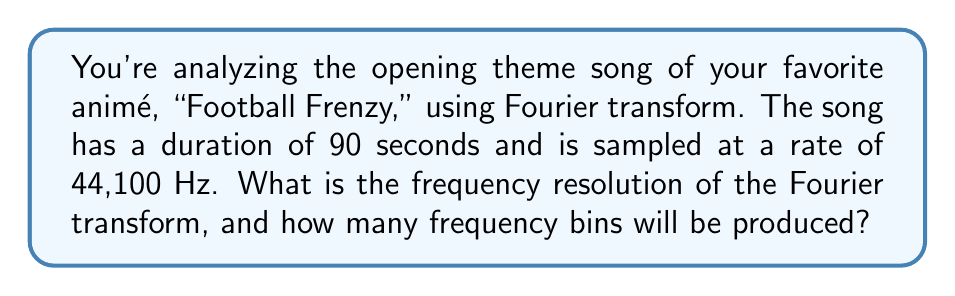Give your solution to this math problem. To solve this problem, we need to understand two key concepts of the Fourier transform:

1. Frequency resolution
2. Number of frequency bins

Let's break it down step-by-step:

1. Frequency Resolution:
   The frequency resolution (Δf) is given by the formula:
   
   $$\Delta f = \frac{f_s}{N}$$
   
   Where $f_s$ is the sampling frequency, and $N$ is the total number of samples.

   We know $f_s = 44,100$ Hz
   To find $N$, we multiply the duration by the sampling rate:
   $N = 90 \text{ seconds} \times 44,100 \text{ Hz} = 3,969,000 \text{ samples}$

   Therefore:
   $$\Delta f = \frac{44,100}{3,969,000} = 0.0111 \text{ Hz}$$

2. Number of Frequency Bins:
   The number of unique frequency bins is given by:
   
   $$\text{Number of bins} = \frac{N}{2} + 1$$

   Where $N$ is the total number of samples.

   $$\text{Number of bins} = \frac{3,969,000}{2} + 1 = 1,984,501$$

This means the Fourier transform will produce 1,984,501 frequency bins, each separated by 0.0111 Hz.
Answer: Frequency resolution: 0.0111 Hz
Number of frequency bins: 1,984,501 